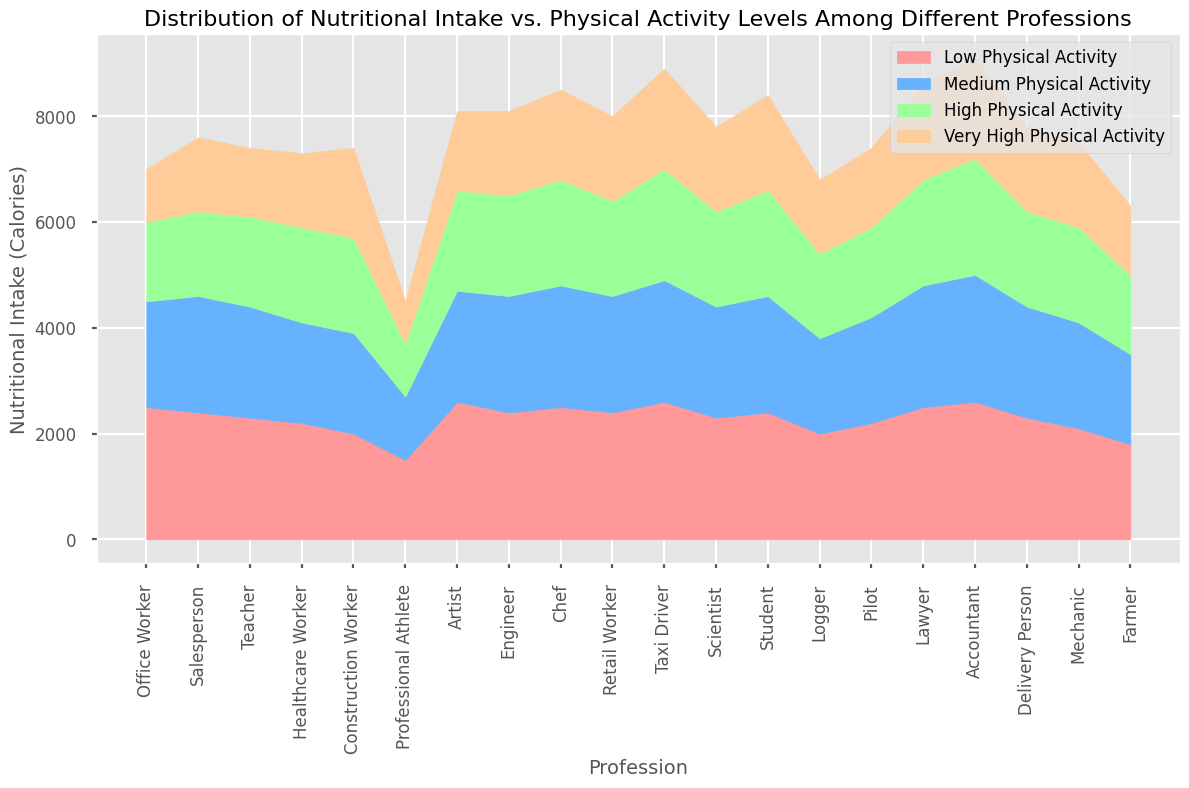What profession consumes the least calories at High Physical Activity level? By observing the chart, locate the section labeled "High Physical Activity" for each profession. The shortest/highest section in this category indicates the profession with the least caloric intake. Professional Athlete has the shortest section in the "High Physical Activity" level.
Answer: Professional Athlete Which profession has the highest nutritional intake at Very High Physical Activity level? Locate and compare the areas represented by "Very High Physical Activity" for each profession. Taxi Driver has the tallest section in this category, indicating the highest caloric intake.
Answer: Taxi Driver Do office workers or chefs consume more calories overall at Medium Physical Activity level? Compare the height of the "Medium Physical Activity" sections for Office Worker and Chef. Chef's section is taller in this category.
Answer: Chef Which profession shows the greatest decrease in nutritional intake from Low to Very High Physical Activity levels? Compare the difference in heights from "Low Physical Activity" to "Very High Physical Activity" within each profession. Office Worker has a substantial reduction from 2500 to 1000 calories between these levels.
Answer: Office Worker Do healthcare workers or engineers show a greater caloric intake at High Physical Activity level? Compare the heights of the "High Physical Activity" sections for Healthcare Worker and Engineer. Engineer has a taller section than Healthcare Worker.
Answer: Engineer How does the caloric intake for artists at Medium Physical Activity level compare with construction workers at High Physical Activity level? Locate the "Medium Physical Activity" section for Artists and the "High Physical Activity" section for Construction Workers. Artists consume 2100 calories, while Construction Workers consume 1800 calories.
Answer: Artists consume 300 more calories Which professions consume more than 2000 calories at Low Physical Activity level? Identify the professions with "Low Physical Activity" sections exceeding the 2000 calorie mark. These include Office Worker, Salesperson, Teacher, Artist, Chef, Taxi Driver, Lawyer, Accountant.
Answer: Office Worker, Salesperson, Teacher, Artist, Chef, Taxi Driver, Lawyer, Accountant What is the total caloric intake at High Physical Activity level for Professional Athletes and Loggers combined? Sum the caloric intakes of Professional Athletes and Loggers at "High Physical Activity" levels, which are 1000 and 1600 respectively. The total is 1000 + 1600 = 2600.
Answer: 2600 Which profession consumes the most consistent calories across the four physical activity levels? Compare the caloric intake across all four activity levels for each profession. Construction Worker shows the least variation, 2000, 1900, 1800, 1700 respectively.
Answer: Construction Worker 